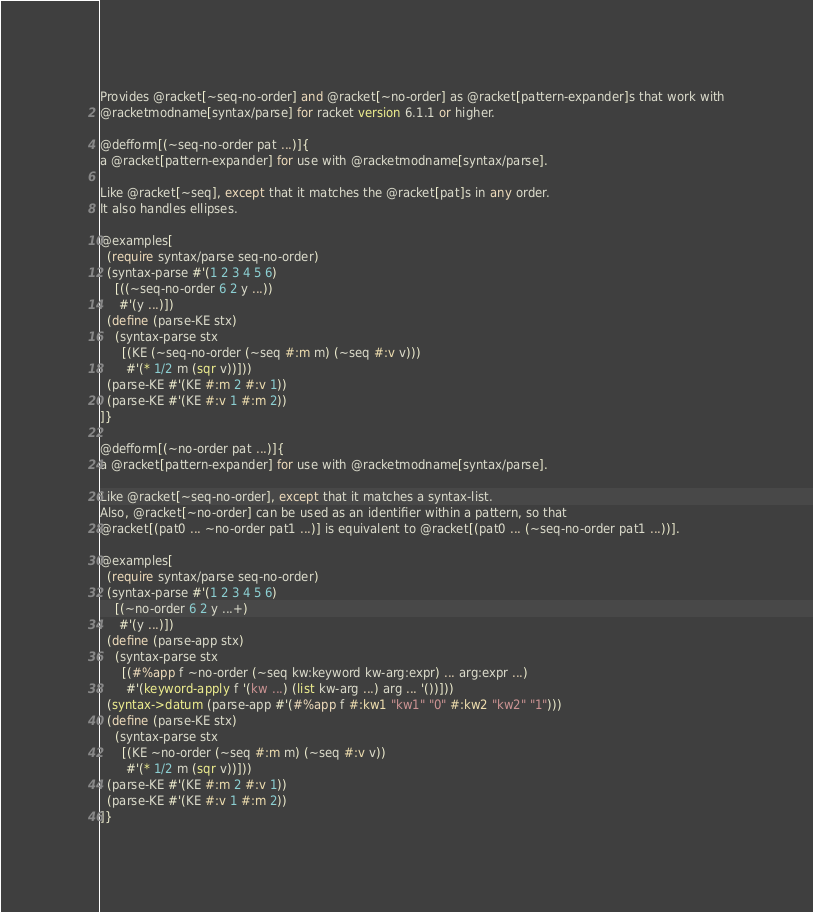<code> <loc_0><loc_0><loc_500><loc_500><_Racket_>Provides @racket[~seq-no-order] and @racket[~no-order] as @racket[pattern-expander]s that work with
@racketmodname[syntax/parse] for racket version 6.1.1 or higher.

@defform[(~seq-no-order pat ...)]{
a @racket[pattern-expander] for use with @racketmodname[syntax/parse].  

Like @racket[~seq], except that it matches the @racket[pat]s in any order.  
It also handles ellipses.

@examples[
  (require syntax/parse seq-no-order)
  (syntax-parse #'(1 2 3 4 5 6)
    [((~seq-no-order 6 2 y ...))
     #'(y ...)])
  (define (parse-KE stx)
    (syntax-parse stx
      [(KE (~seq-no-order (~seq #:m m) (~seq #:v v)))
       #'(* 1/2 m (sqr v))]))
  (parse-KE #'(KE #:m 2 #:v 1))
  (parse-KE #'(KE #:v 1 #:m 2))
]}

@defform[(~no-order pat ...)]{
a @racket[pattern-expander] for use with @racketmodname[syntax/parse].  

Like @racket[~seq-no-order], except that it matches a syntax-list.  
Also, @racket[~no-order] can be used as an identifier within a pattern, so that
@racket[(pat0 ... ~no-order pat1 ...)] is equivalent to @racket[(pat0 ... (~seq-no-order pat1 ...))]. 

@examples[
  (require syntax/parse seq-no-order)
  (syntax-parse #'(1 2 3 4 5 6)
    [(~no-order 6 2 y ...+)
     #'(y ...)])
  (define (parse-app stx)
    (syntax-parse stx
      [(#%app f ~no-order (~seq kw:keyword kw-arg:expr) ... arg:expr ...)
       #'(keyword-apply f '(kw ...) (list kw-arg ...) arg ... '())]))
  (syntax->datum (parse-app #'(#%app f #:kw1 "kw1" "0" #:kw2 "kw2" "1")))
  (define (parse-KE stx)
    (syntax-parse stx
      [(KE ~no-order (~seq #:m m) (~seq #:v v))
       #'(* 1/2 m (sqr v))]))
  (parse-KE #'(KE #:m 2 #:v 1))
  (parse-KE #'(KE #:v 1 #:m 2))
]}

</code> 